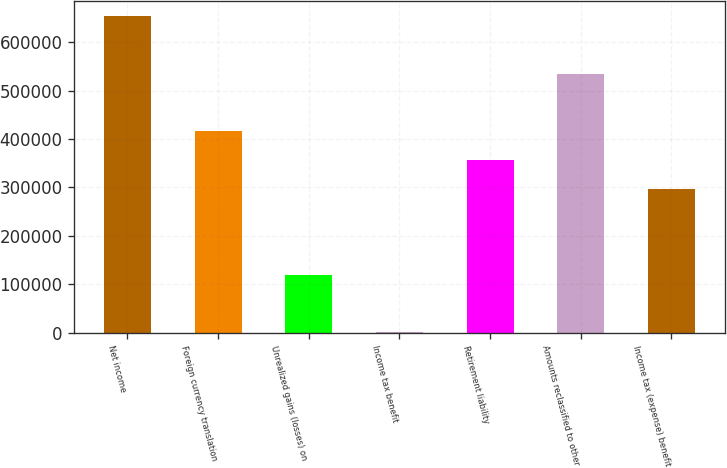Convert chart. <chart><loc_0><loc_0><loc_500><loc_500><bar_chart><fcel>Net income<fcel>Foreign currency translation<fcel>Unrealized gains (losses) on<fcel>Income tax benefit<fcel>Retirement liability<fcel>Amounts reclassified to other<fcel>Income tax (expense) benefit<nl><fcel>653129<fcel>415789<fcel>119113<fcel>443<fcel>356454<fcel>534459<fcel>297118<nl></chart> 